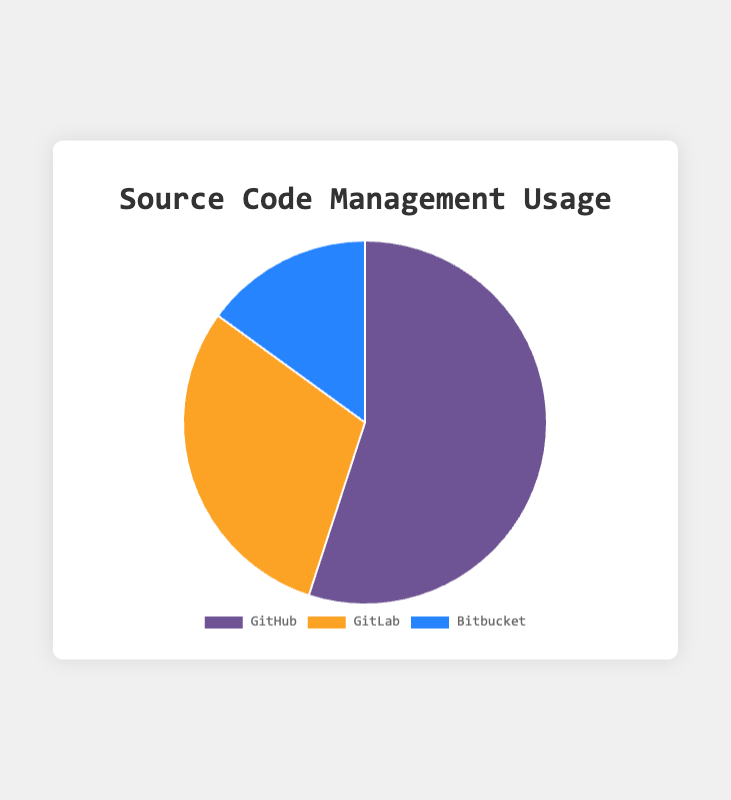What is the most popular source code management platform? The most popular platform is identified by the largest portion of the pie chart. GitHub has the largest segment.
Answer: GitHub Which source code management platform is used the least? The least used platform is identified by the smallest portion of the pie chart. Bitbucket has the smallest segment.
Answer: Bitbucket How much more popular is GitHub compared to GitLab? To find how much more popular GitHub is compared to GitLab, subtract GitLab's percentage from GitHub's percentage: 55% - 30% = 25%.
Answer: 25% What is the combined percentage usage of GitLab and Bitbucket? To find the combined percentage, add the percentages of GitLab and Bitbucket: 30% + 15% = 45%.
Answer: 45% Which platform accounts for more than half of the source code management usage? Any platform with more than 50% of the total usage will fit this description. GitHub is 55%, which is more than half.
Answer: GitHub Which color represents GitLab on the pie chart? Look for the segment labeled "GitLab" and note its color. GitLab is represented by the color orange.
Answer: Orange If you combine GitHub and Bitbucket, what percentage of source code management platforms do they represent? Add the percentages of GitHub and Bitbucket: 55% + 15% = 70%.
Answer: 70% Which two platforms combined have the same usage as GitHub alone? GitHub has 55%. The combination of GitLab (30%) and Bitbucket (15%) equals 45%, which is less than 55%. Therefore, no two platforms combined have the same usage as GitHub alone.
Answer: None Is GitLab more or less popular than the combined usage of Bitbucket and GitHub? GitLab is 30%. The combined usage of Bitbucket and GitHub is 15% + 55% = 70%. Thus, GitLab is less popular.
Answer: Less What percentage of the total usage does the smallest segment represent? The smallest segment is Bitbucket which represents 15%.
Answer: 15% 